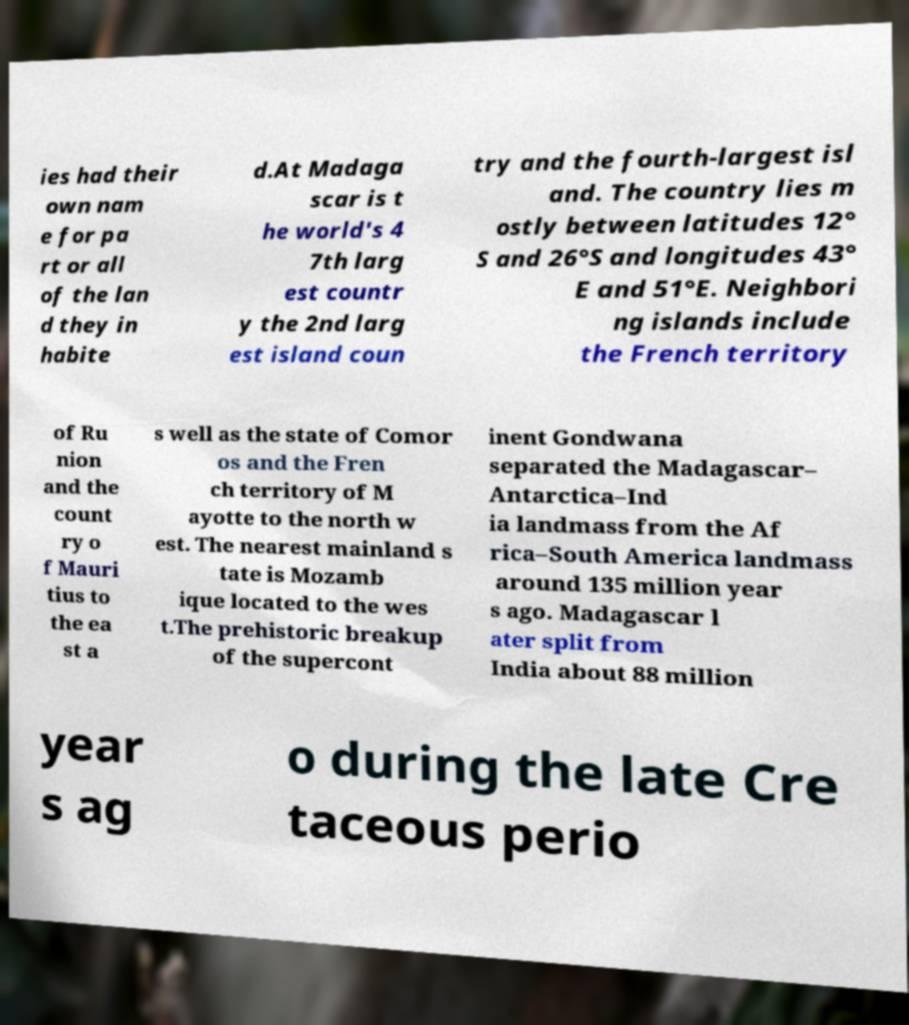Please identify and transcribe the text found in this image. ies had their own nam e for pa rt or all of the lan d they in habite d.At Madaga scar is t he world's 4 7th larg est countr y the 2nd larg est island coun try and the fourth-largest isl and. The country lies m ostly between latitudes 12° S and 26°S and longitudes 43° E and 51°E. Neighbori ng islands include the French territory of Ru nion and the count ry o f Mauri tius to the ea st a s well as the state of Comor os and the Fren ch territory of M ayotte to the north w est. The nearest mainland s tate is Mozamb ique located to the wes t.The prehistoric breakup of the supercont inent Gondwana separated the Madagascar– Antarctica–Ind ia landmass from the Af rica–South America landmass around 135 million year s ago. Madagascar l ater split from India about 88 million year s ag o during the late Cre taceous perio 